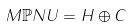<formula> <loc_0><loc_0><loc_500><loc_500>M \mathbb { P } N U = H \oplus C</formula> 